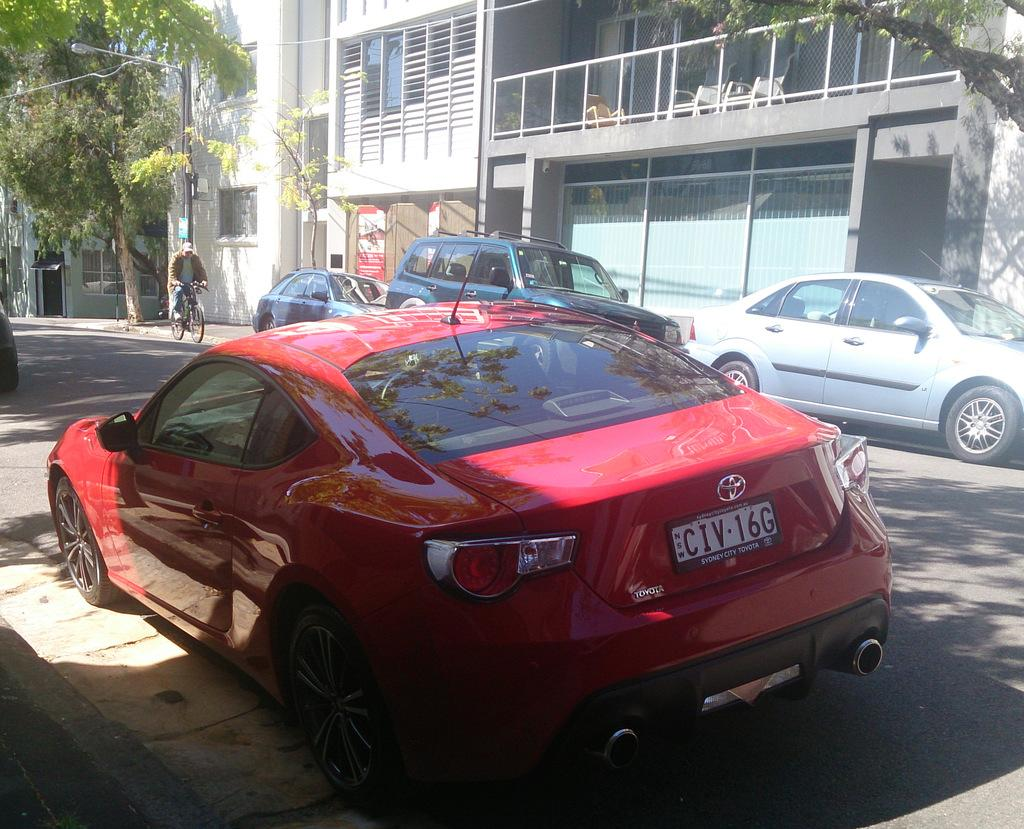What is the main subject in the center of the image? There is a car in the center of the image. Where is the car located? The car is on the road. What other vehicles can be seen in the image? There are cars in the background of the image. What architectural features are visible in the background? There are doors, windows, and a building in the background of the image. What type of person is present in the background? There is a person in the background of the image. What mode of transportation can be seen in the background? There is a cycle in the background of the image. What natural elements are visible in the background? There are trees in the background of the image. What man-made object is present in the background? There is a street light in the background of the image. Is there any snow visible in the image? No, there is no snow present in the image. What type of ball is being used by the laborer in the image? There is no laborer or ball present in the image. 